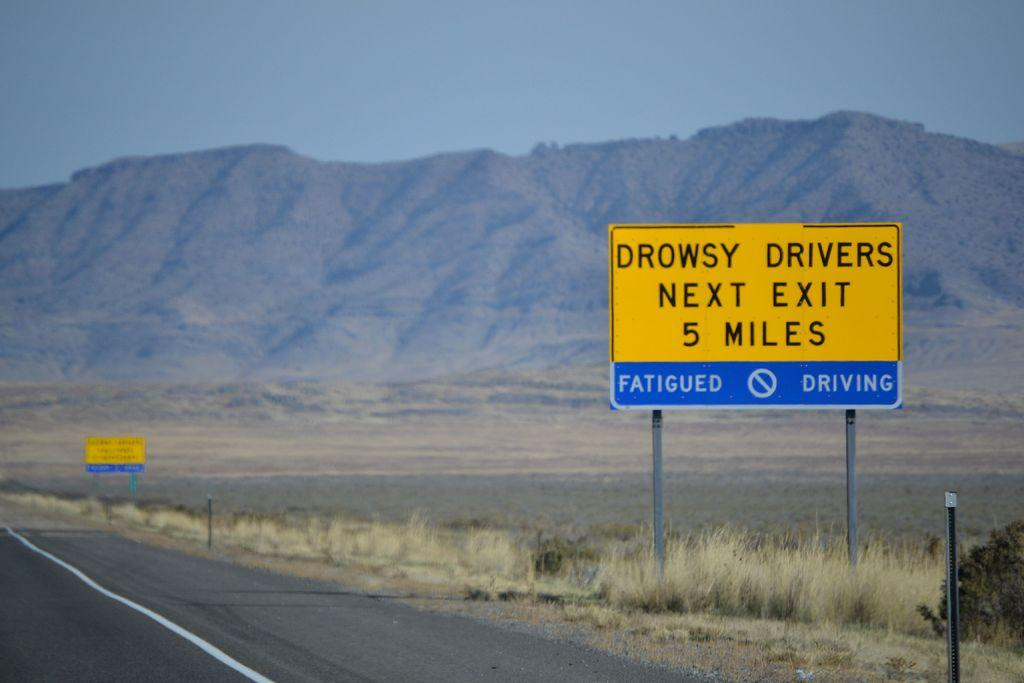<image>
Present a compact description of the photo's key features. A yellow sign says that drowsy drivers should take the next exit in 5 miles. 